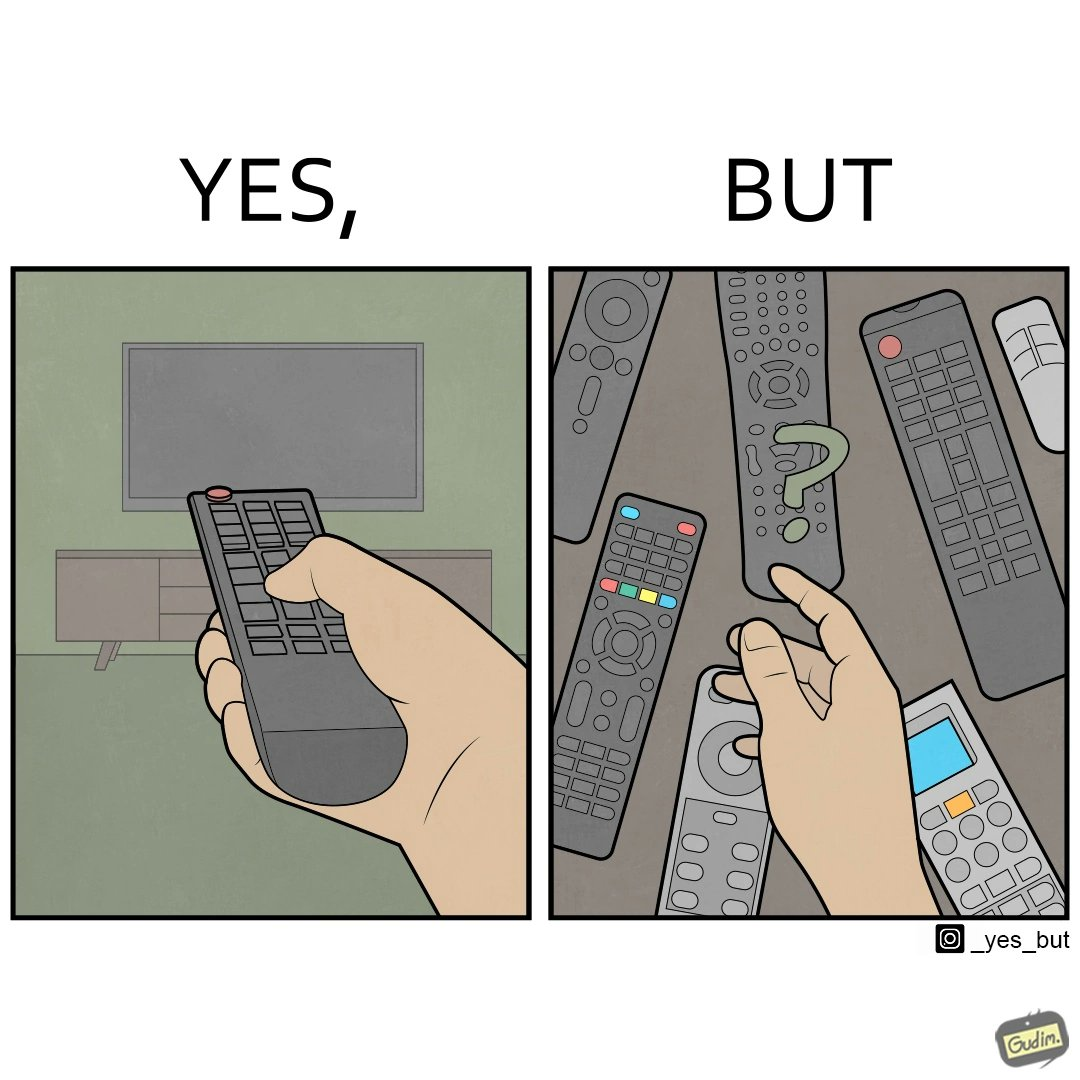Explain why this image is satirical. The images are funny since they show how even though TV remotes are supposed to make operating TVs easier, having multiple similar looking remotes  for everything only makes it more difficult for the user to use the right one 